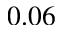<formula> <loc_0><loc_0><loc_500><loc_500>0 . 0 6</formula> 